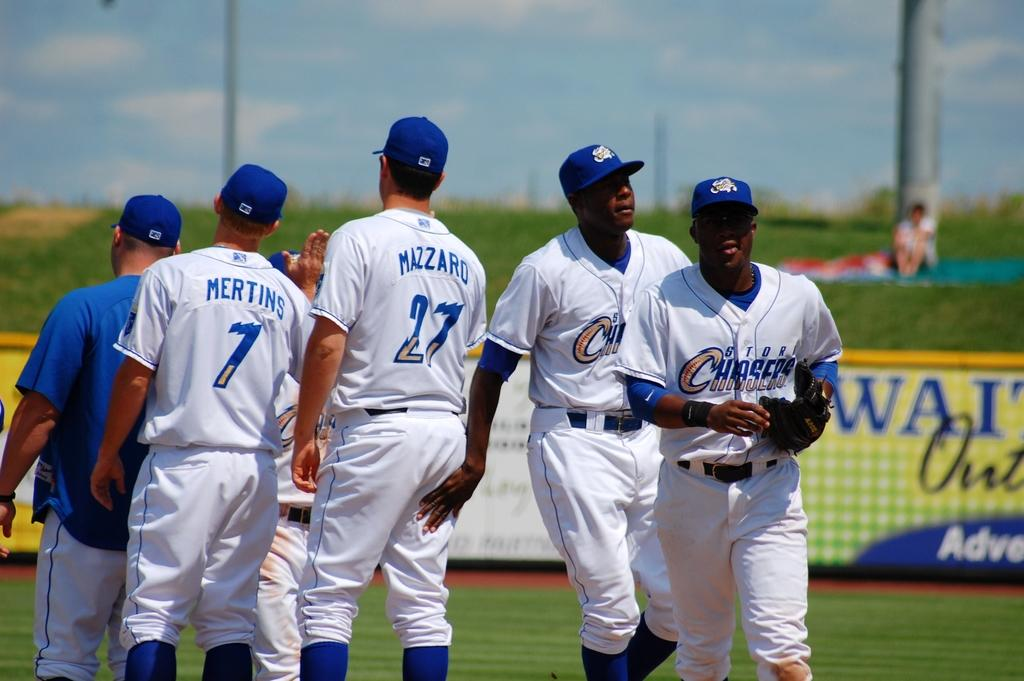Provide a one-sentence caption for the provided image. A group of baseball player with a blue and white uniform that says Chasers. 